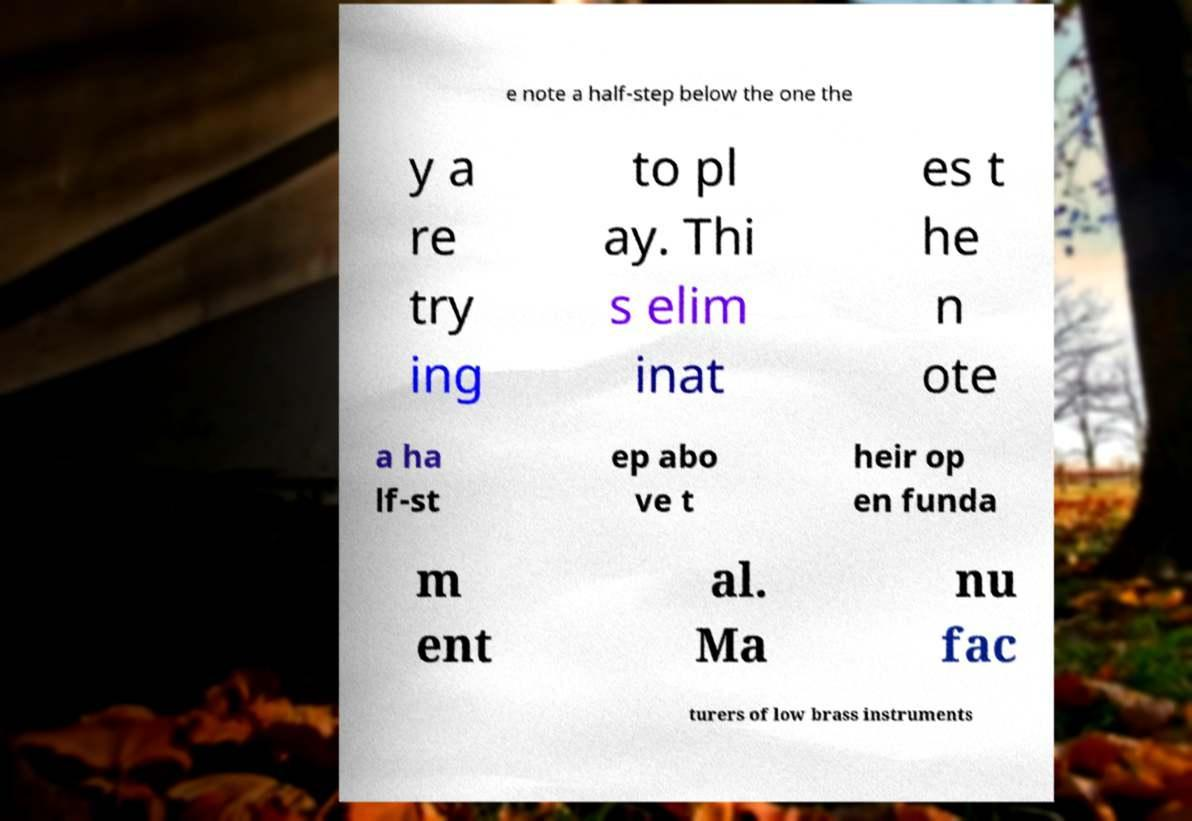Could you assist in decoding the text presented in this image and type it out clearly? e note a half-step below the one the y a re try ing to pl ay. Thi s elim inat es t he n ote a ha lf-st ep abo ve t heir op en funda m ent al. Ma nu fac turers of low brass instruments 